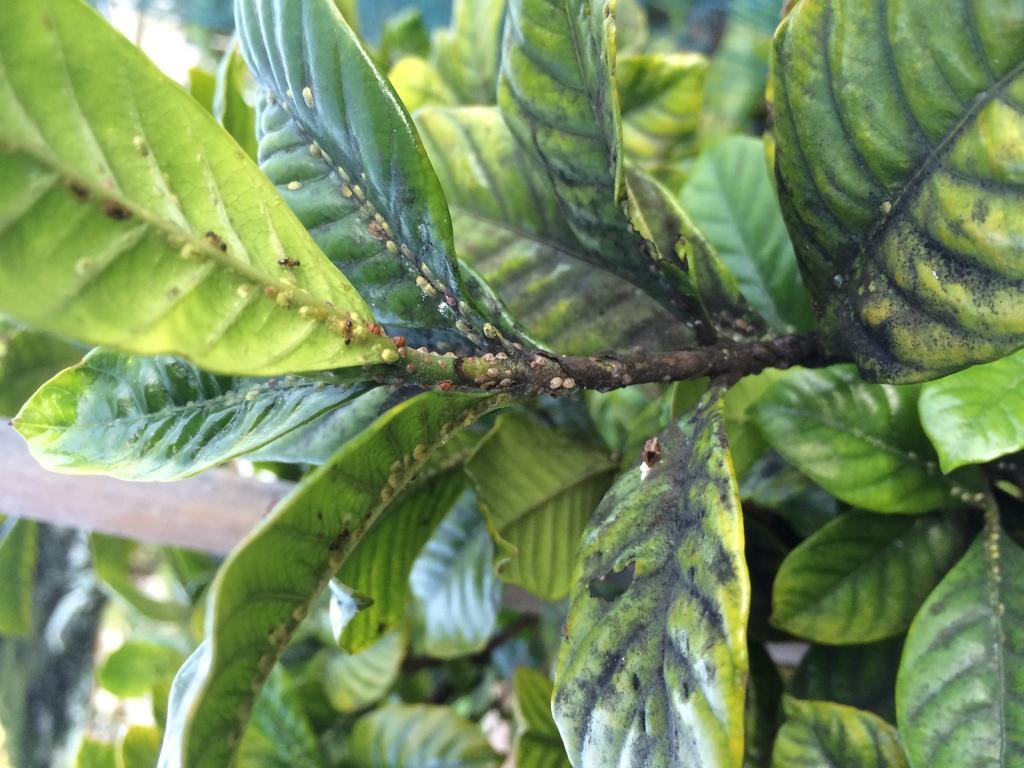Can you describe this image briefly? In this image, we can see some plants and a pole. 